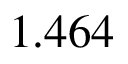Convert formula to latex. <formula><loc_0><loc_0><loc_500><loc_500>1 . 4 6 4</formula> 